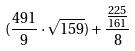<formula> <loc_0><loc_0><loc_500><loc_500>( \frac { 4 9 1 } { 9 } \cdot \sqrt { 1 5 9 } ) + \frac { \frac { 2 2 5 } { 1 6 1 } } { 8 }</formula> 